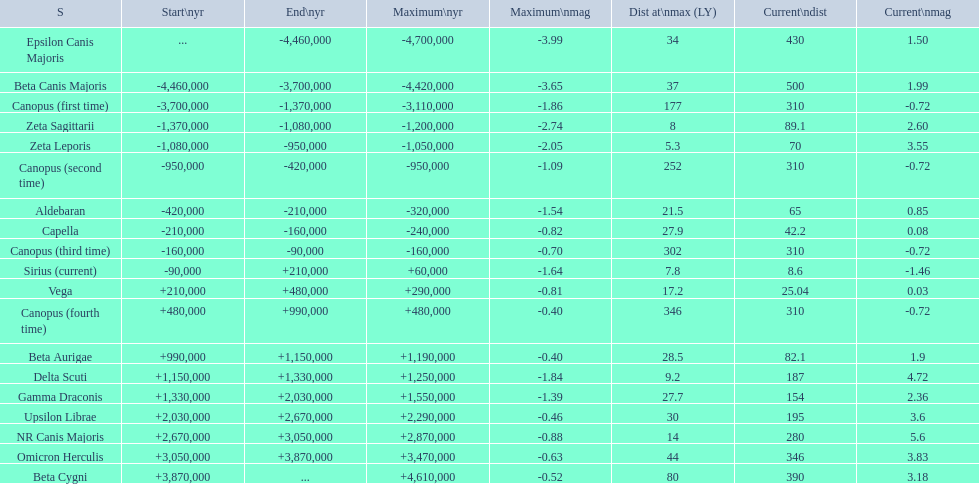What are the historical brightest stars? Epsilon Canis Majoris, Beta Canis Majoris, Canopus (first time), Zeta Sagittarii, Zeta Leporis, Canopus (second time), Aldebaran, Capella, Canopus (third time), Sirius (current), Vega, Canopus (fourth time), Beta Aurigae, Delta Scuti, Gamma Draconis, Upsilon Librae, NR Canis Majoris, Omicron Herculis, Beta Cygni. Of those which star has a distance at maximum of 80 Beta Cygni. 